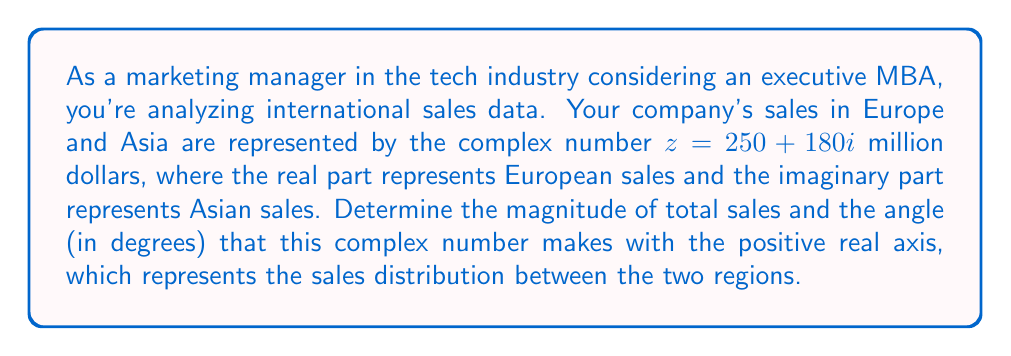Solve this math problem. To solve this problem, we need to calculate the magnitude and argument of the complex number $z = 250 + 180i$.

1. Magnitude (total sales):
   The magnitude of a complex number $z = a + bi$ is given by $|z| = \sqrt{a^2 + b^2}$.
   
   $$|z| = \sqrt{250^2 + 180^2} = \sqrt{62500 + 32400} = \sqrt{94900} \approx 308.06$$

2. Argument (angle):
   The argument of a complex number is given by $\theta = \arctan(\frac{b}{a})$, where $a$ is the real part and $b$ is the imaginary part.
   
   $$\theta = \arctan(\frac{180}{250}) \approx 0.6235 \text{ radians}$$

   To convert radians to degrees, multiply by $\frac{180°}{\pi}$:
   
   $$\theta \text{ in degrees} = 0.6235 \times \frac{180°}{\pi} \approx 35.75°$$

The magnitude represents the total sales in millions of dollars, and the angle represents the distribution of sales between Europe and Asia, with 0° corresponding to purely European sales and 90° corresponding to purely Asian sales.
Answer: Magnitude (total sales): $308.06$ million dollars
Angle: $35.75°$ 